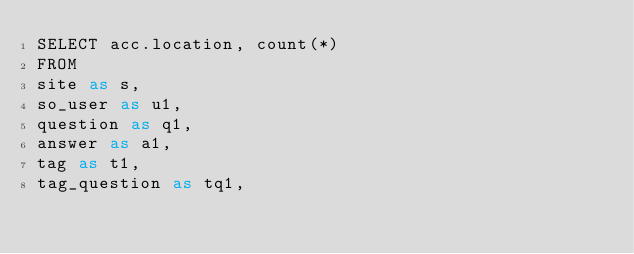<code> <loc_0><loc_0><loc_500><loc_500><_SQL_>SELECT acc.location, count(*)
FROM
site as s,
so_user as u1,
question as q1,
answer as a1,
tag as t1,
tag_question as tq1,</code> 